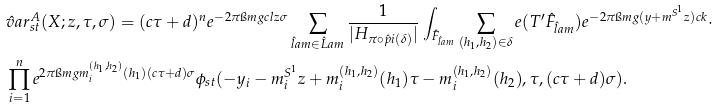Convert formula to latex. <formula><loc_0><loc_0><loc_500><loc_500>& \hat { v } a r _ { s t } ^ { A } ( X ; z , \tau , \sigma ) = ( c \tau + d ) ^ { n } e ^ { - 2 \pi \i m g c l z \sigma } \sum _ { \hat { l } a m \in \hat { L } a m } \frac { 1 } { | H _ { \pi \circ \hat { p } i ( \delta ) } | } \int _ { \hat { F } _ { \hat { l } a m } } \sum _ { ( h _ { 1 } , h _ { 2 } ) \in \delta } e ( T ^ { \prime } \hat { F } _ { \hat { l } a m } ) e ^ { - 2 \pi \i m g ( y + m ^ { S ^ { 1 } } z ) c k } \cdot \\ & \prod _ { i = 1 } ^ { n } e ^ { 2 \pi \i m g m _ { i } ^ { ( h _ { 1 } , h _ { 2 } ) } ( h _ { 1 } ) ( c \tau + d ) \sigma } \phi _ { s t } ( - y _ { i } - m _ { i } ^ { S ^ { 1 } } z + m _ { i } ^ { ( h _ { 1 } , h _ { 2 } ) } ( h _ { 1 } ) \tau - m _ { i } ^ { ( h _ { 1 } , h _ { 2 } ) } ( h _ { 2 } ) , \tau , ( c \tau + d ) \sigma ) .</formula> 